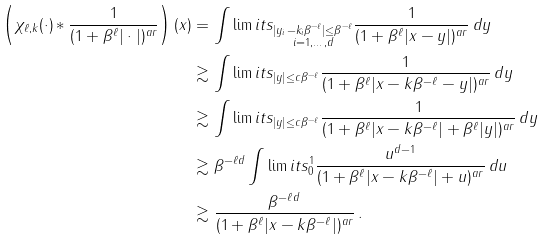Convert formula to latex. <formula><loc_0><loc_0><loc_500><loc_500>\left ( \chi _ { \ell , k } ( \cdot ) \ast \frac { 1 } { ( 1 + \beta ^ { \ell } | \cdot | ) ^ { a r } } \right ) ( x ) & = \int \lim i t s _ { \substack { | y _ { i } - k _ { i } \beta ^ { - \ell } | \leq \beta ^ { - \ell } \\ i = 1 , \dots , d } } \frac { 1 } { ( 1 + \beta ^ { \ell } | x - y | ) ^ { a r } } \, d y \\ & \gtrsim \int \lim i t s _ { | y | \leq c \beta ^ { - \ell } } \frac { 1 } { ( 1 + \beta ^ { \ell } | x - k \beta ^ { - \ell } - y | ) ^ { a r } } \, d y \\ & \gtrsim \int \lim i t s _ { | y | \leq c \beta ^ { - \ell } } \frac { 1 } { ( 1 + \beta ^ { \ell } | x - k \beta ^ { - \ell } | + \beta ^ { \ell } | y | ) ^ { a r } } \, d y \\ & \gtrsim \beta ^ { - \ell d } \int \lim i t s _ { 0 } ^ { 1 } \frac { u ^ { d - 1 } } { ( 1 + \beta ^ { \ell } | x - k \beta ^ { - \ell } | + u ) ^ { a r } } \, d u \\ & \gtrsim \frac { \beta ^ { - \ell d } } { ( 1 + \beta ^ { \ell } | x - k \beta ^ { - \ell } | ) ^ { a r } } \, .</formula> 